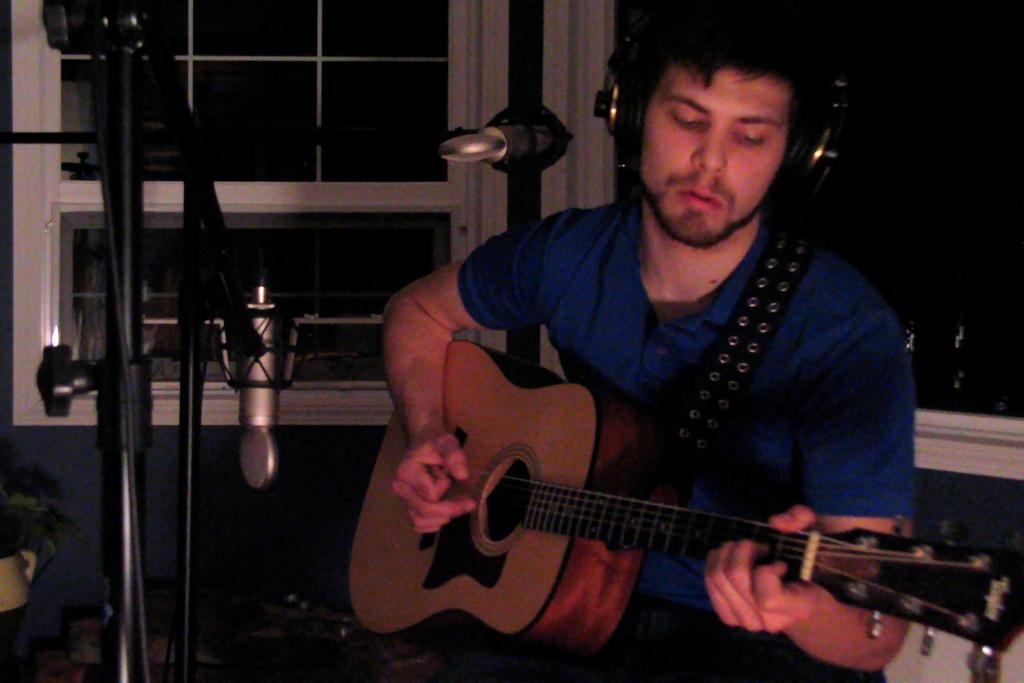Where was the image taken? The image was taken in a closed room. What is the person in the image doing? The person is playing a guitar. What is the person wearing? The person is wearing a blue shirt. What object is the person in front of? The person is in front of a microphone. Is there any natural light source visible in the image? Yes, there is a window behind the person. What type of wool is being spun by the person in the image? There is no wool or spinning activity present in the image; the person is playing a guitar. 